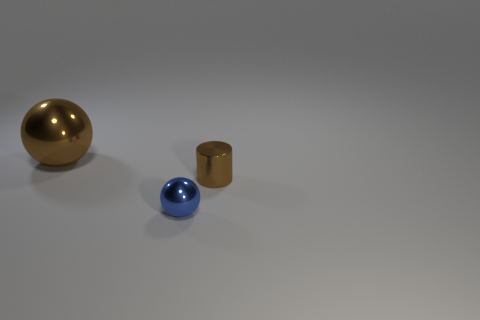Add 1 large yellow cylinders. How many objects exist? 4 Subtract all cylinders. How many objects are left? 2 Subtract all tiny cylinders. Subtract all metallic spheres. How many objects are left? 0 Add 2 brown metallic things. How many brown metallic things are left? 4 Add 2 large gray cylinders. How many large gray cylinders exist? 2 Subtract 0 cyan cubes. How many objects are left? 3 